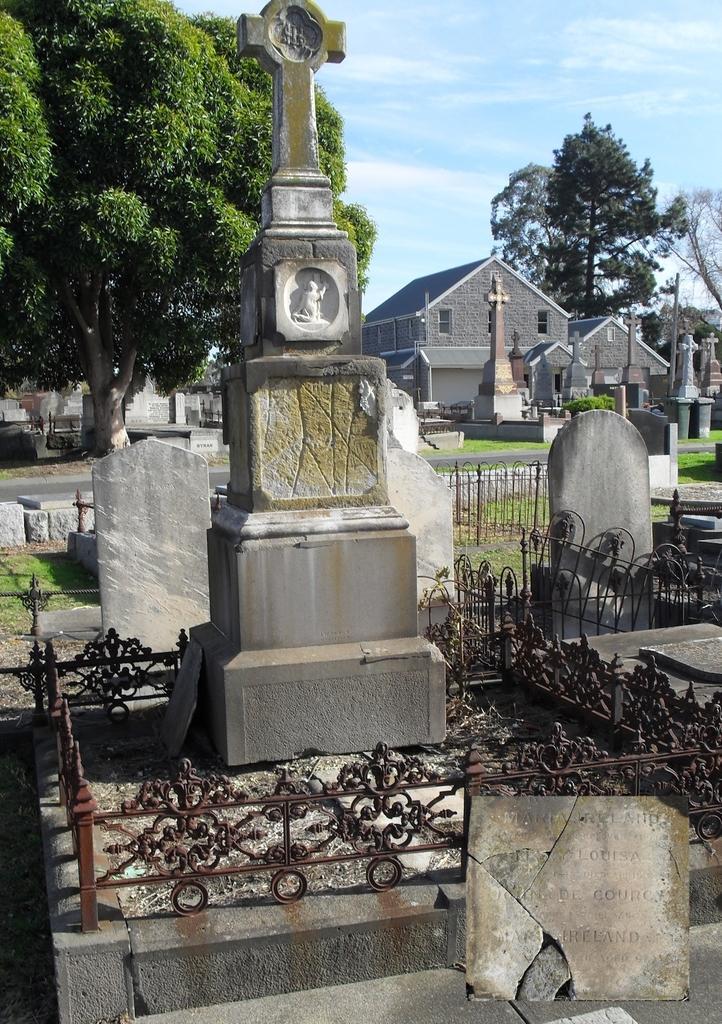Can you describe this image briefly? In the center of the image we can see graveyard. In the background we can see graveyard, buildings, trees, road, sky and clouds. 